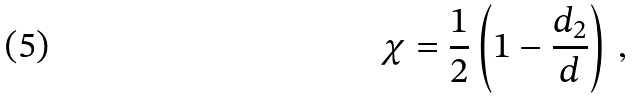<formula> <loc_0><loc_0><loc_500><loc_500>\chi = \frac { 1 } { 2 } \left ( 1 - \frac { d _ { 2 } } { d } \right ) \, ,</formula> 